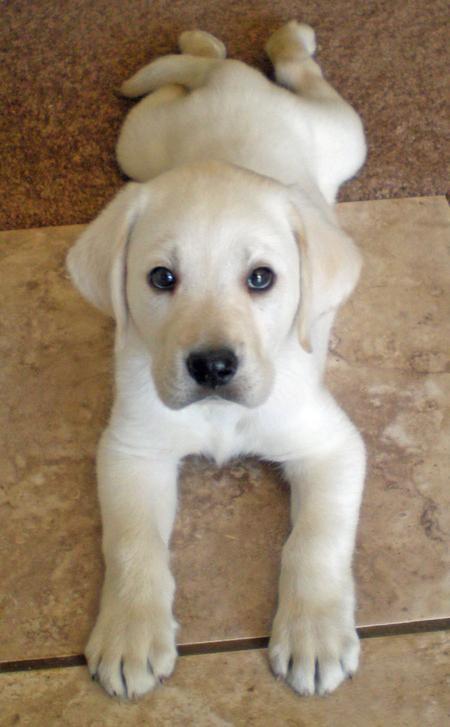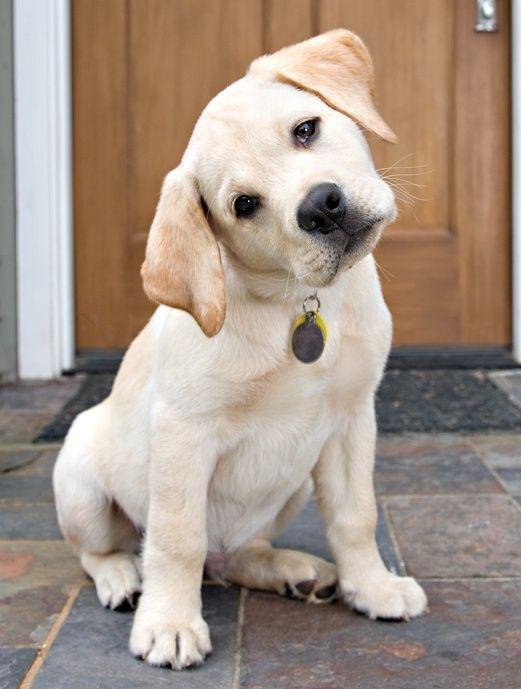The first image is the image on the left, the second image is the image on the right. Given the left and right images, does the statement "One dog has a toy." hold true? Answer yes or no. No. The first image is the image on the left, the second image is the image on the right. Evaluate the accuracy of this statement regarding the images: "No puppy is standing, and exactly one puppy is reclining with front paws extended in front of its body.". Is it true? Answer yes or no. Yes. 